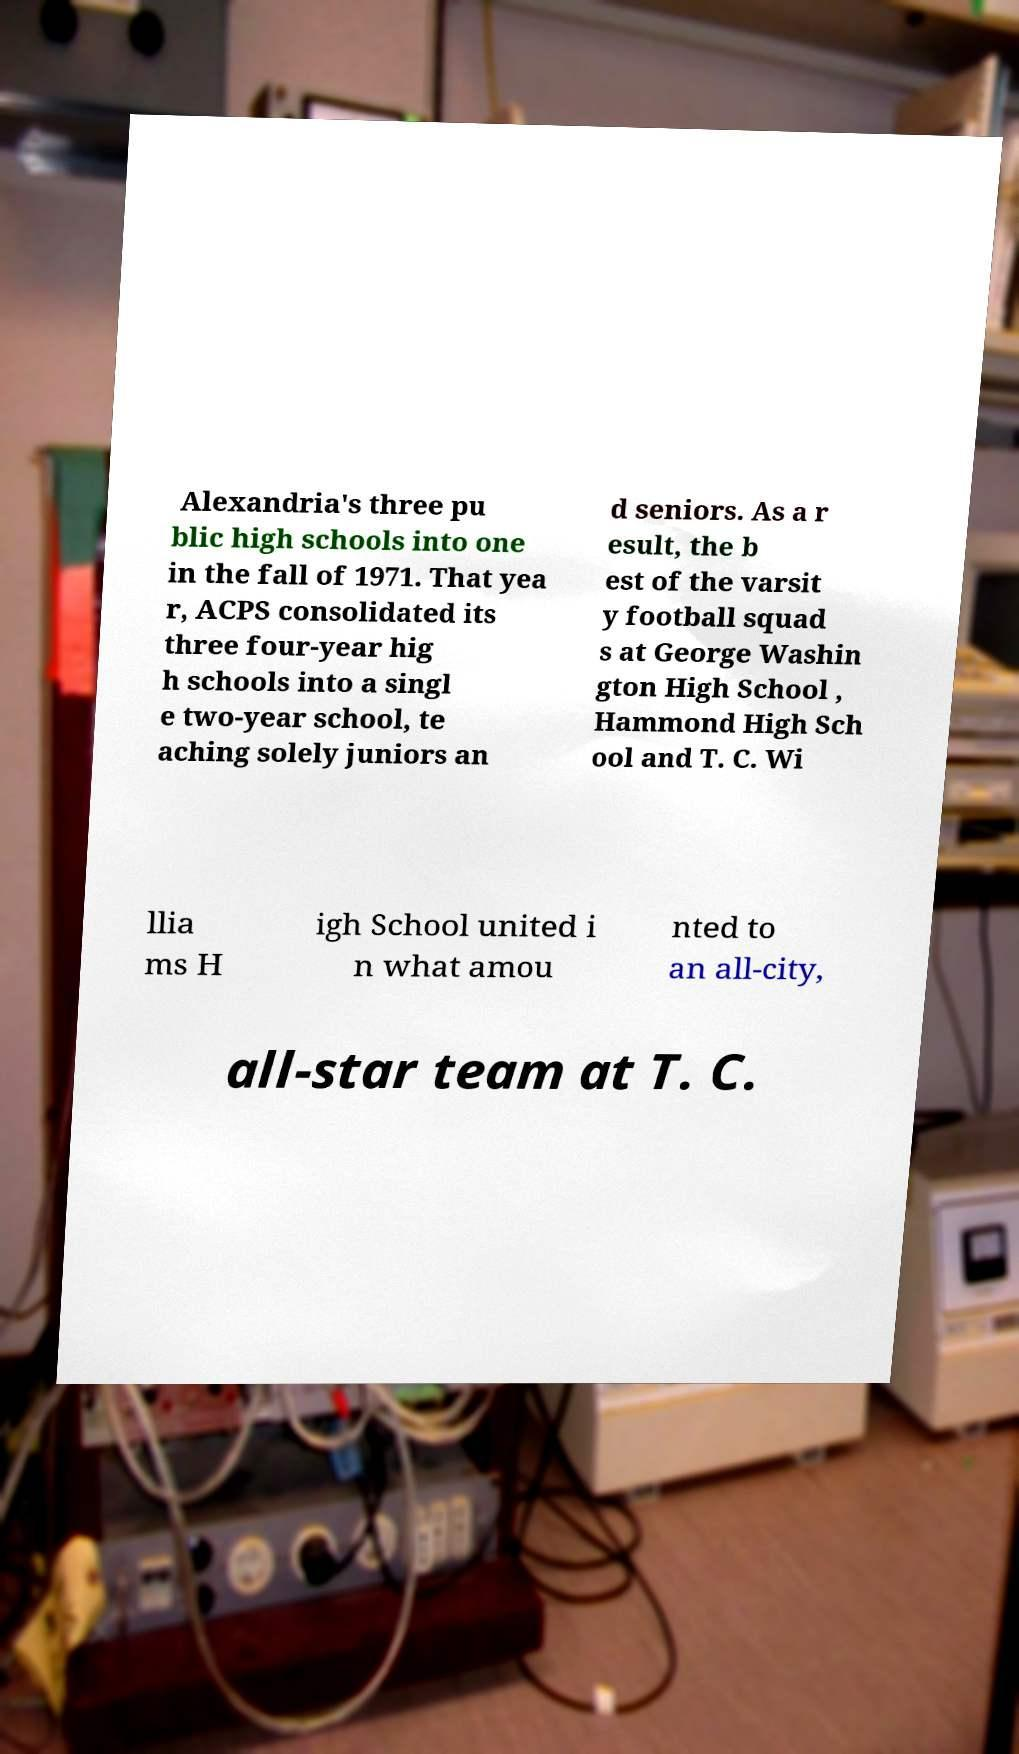I need the written content from this picture converted into text. Can you do that? Alexandria's three pu blic high schools into one in the fall of 1971. That yea r, ACPS consolidated its three four-year hig h schools into a singl e two-year school, te aching solely juniors an d seniors. As a r esult, the b est of the varsit y football squad s at George Washin gton High School , Hammond High Sch ool and T. C. Wi llia ms H igh School united i n what amou nted to an all-city, all-star team at T. C. 